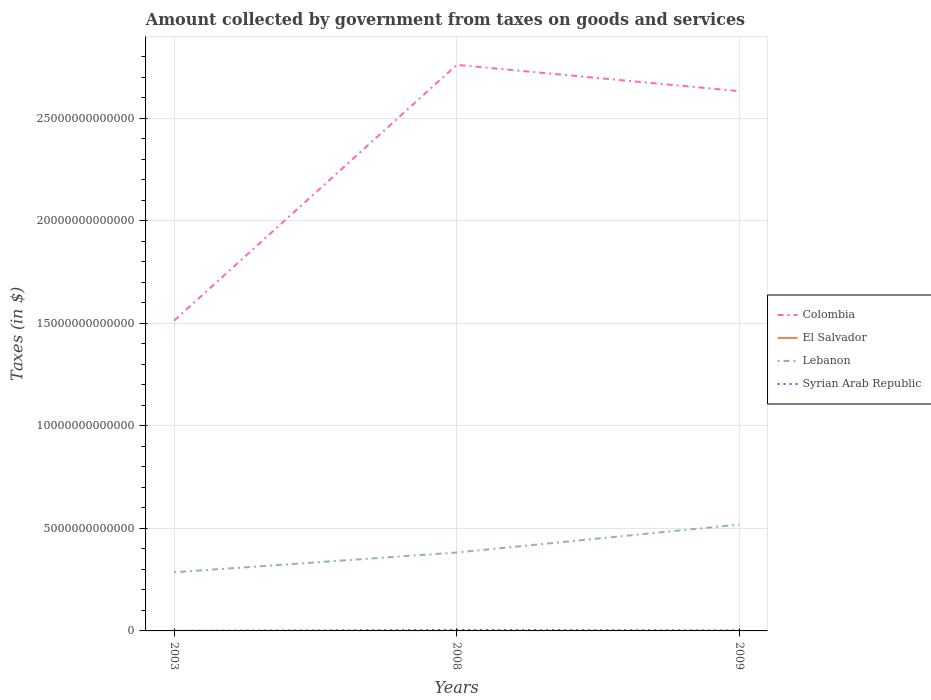Across all years, what is the maximum amount collected by government from taxes on goods and services in Syrian Arab Republic?
Offer a terse response. 3.82e+09. What is the total amount collected by government from taxes on goods and services in Lebanon in the graph?
Ensure brevity in your answer.  -9.64e+11. What is the difference between the highest and the second highest amount collected by government from taxes on goods and services in El Salvador?
Provide a short and direct response. 8.16e+08. Is the amount collected by government from taxes on goods and services in Syrian Arab Republic strictly greater than the amount collected by government from taxes on goods and services in El Salvador over the years?
Provide a short and direct response. No. What is the difference between two consecutive major ticks on the Y-axis?
Provide a succinct answer. 5.00e+12. Are the values on the major ticks of Y-axis written in scientific E-notation?
Your response must be concise. No. Does the graph contain grids?
Your answer should be very brief. Yes. How many legend labels are there?
Make the answer very short. 4. What is the title of the graph?
Your answer should be compact. Amount collected by government from taxes on goods and services. What is the label or title of the X-axis?
Make the answer very short. Years. What is the label or title of the Y-axis?
Keep it short and to the point. Taxes (in $). What is the Taxes (in $) of Colombia in 2003?
Give a very brief answer. 1.51e+13. What is the Taxes (in $) of El Salvador in 2003?
Ensure brevity in your answer.  9.86e+08. What is the Taxes (in $) of Lebanon in 2003?
Provide a short and direct response. 2.86e+12. What is the Taxes (in $) of Syrian Arab Republic in 2003?
Your answer should be compact. 3.82e+09. What is the Taxes (in $) in Colombia in 2008?
Ensure brevity in your answer.  2.76e+13. What is the Taxes (in $) in El Salvador in 2008?
Offer a terse response. 1.80e+09. What is the Taxes (in $) in Lebanon in 2008?
Offer a very short reply. 3.82e+12. What is the Taxes (in $) in Syrian Arab Republic in 2008?
Provide a succinct answer. 5.14e+1. What is the Taxes (in $) of Colombia in 2009?
Keep it short and to the point. 2.63e+13. What is the Taxes (in $) of El Salvador in 2009?
Offer a very short reply. 1.44e+09. What is the Taxes (in $) of Lebanon in 2009?
Offer a terse response. 5.18e+12. What is the Taxes (in $) of Syrian Arab Republic in 2009?
Ensure brevity in your answer.  2.60e+1. Across all years, what is the maximum Taxes (in $) of Colombia?
Your answer should be very brief. 2.76e+13. Across all years, what is the maximum Taxes (in $) in El Salvador?
Offer a very short reply. 1.80e+09. Across all years, what is the maximum Taxes (in $) in Lebanon?
Provide a succinct answer. 5.18e+12. Across all years, what is the maximum Taxes (in $) in Syrian Arab Republic?
Your answer should be very brief. 5.14e+1. Across all years, what is the minimum Taxes (in $) in Colombia?
Offer a terse response. 1.51e+13. Across all years, what is the minimum Taxes (in $) of El Salvador?
Provide a succinct answer. 9.86e+08. Across all years, what is the minimum Taxes (in $) in Lebanon?
Keep it short and to the point. 2.86e+12. Across all years, what is the minimum Taxes (in $) in Syrian Arab Republic?
Ensure brevity in your answer.  3.82e+09. What is the total Taxes (in $) of Colombia in the graph?
Keep it short and to the point. 6.90e+13. What is the total Taxes (in $) in El Salvador in the graph?
Your response must be concise. 4.23e+09. What is the total Taxes (in $) of Lebanon in the graph?
Give a very brief answer. 1.19e+13. What is the total Taxes (in $) in Syrian Arab Republic in the graph?
Make the answer very short. 8.12e+1. What is the difference between the Taxes (in $) of Colombia in 2003 and that in 2008?
Ensure brevity in your answer.  -1.25e+13. What is the difference between the Taxes (in $) in El Salvador in 2003 and that in 2008?
Offer a terse response. -8.16e+08. What is the difference between the Taxes (in $) of Lebanon in 2003 and that in 2008?
Your answer should be compact. -9.64e+11. What is the difference between the Taxes (in $) of Syrian Arab Republic in 2003 and that in 2008?
Offer a very short reply. -4.76e+1. What is the difference between the Taxes (in $) of Colombia in 2003 and that in 2009?
Your answer should be compact. -1.12e+13. What is the difference between the Taxes (in $) of El Salvador in 2003 and that in 2009?
Your response must be concise. -4.54e+08. What is the difference between the Taxes (in $) in Lebanon in 2003 and that in 2009?
Offer a very short reply. -2.33e+12. What is the difference between the Taxes (in $) in Syrian Arab Republic in 2003 and that in 2009?
Provide a short and direct response. -2.21e+1. What is the difference between the Taxes (in $) in Colombia in 2008 and that in 2009?
Provide a short and direct response. 1.28e+12. What is the difference between the Taxes (in $) of El Salvador in 2008 and that in 2009?
Provide a short and direct response. 3.62e+08. What is the difference between the Taxes (in $) in Lebanon in 2008 and that in 2009?
Your response must be concise. -1.36e+12. What is the difference between the Taxes (in $) in Syrian Arab Republic in 2008 and that in 2009?
Offer a very short reply. 2.54e+1. What is the difference between the Taxes (in $) of Colombia in 2003 and the Taxes (in $) of El Salvador in 2008?
Your answer should be very brief. 1.51e+13. What is the difference between the Taxes (in $) in Colombia in 2003 and the Taxes (in $) in Lebanon in 2008?
Your answer should be very brief. 1.13e+13. What is the difference between the Taxes (in $) in Colombia in 2003 and the Taxes (in $) in Syrian Arab Republic in 2008?
Offer a very short reply. 1.51e+13. What is the difference between the Taxes (in $) of El Salvador in 2003 and the Taxes (in $) of Lebanon in 2008?
Offer a terse response. -3.82e+12. What is the difference between the Taxes (in $) of El Salvador in 2003 and the Taxes (in $) of Syrian Arab Republic in 2008?
Give a very brief answer. -5.04e+1. What is the difference between the Taxes (in $) in Lebanon in 2003 and the Taxes (in $) in Syrian Arab Republic in 2008?
Provide a succinct answer. 2.81e+12. What is the difference between the Taxes (in $) in Colombia in 2003 and the Taxes (in $) in El Salvador in 2009?
Offer a very short reply. 1.51e+13. What is the difference between the Taxes (in $) in Colombia in 2003 and the Taxes (in $) in Lebanon in 2009?
Your answer should be very brief. 9.94e+12. What is the difference between the Taxes (in $) in Colombia in 2003 and the Taxes (in $) in Syrian Arab Republic in 2009?
Provide a succinct answer. 1.51e+13. What is the difference between the Taxes (in $) in El Salvador in 2003 and the Taxes (in $) in Lebanon in 2009?
Your answer should be very brief. -5.18e+12. What is the difference between the Taxes (in $) in El Salvador in 2003 and the Taxes (in $) in Syrian Arab Republic in 2009?
Keep it short and to the point. -2.50e+1. What is the difference between the Taxes (in $) in Lebanon in 2003 and the Taxes (in $) in Syrian Arab Republic in 2009?
Your answer should be very brief. 2.83e+12. What is the difference between the Taxes (in $) in Colombia in 2008 and the Taxes (in $) in El Salvador in 2009?
Provide a short and direct response. 2.76e+13. What is the difference between the Taxes (in $) of Colombia in 2008 and the Taxes (in $) of Lebanon in 2009?
Provide a short and direct response. 2.24e+13. What is the difference between the Taxes (in $) in Colombia in 2008 and the Taxes (in $) in Syrian Arab Republic in 2009?
Provide a succinct answer. 2.76e+13. What is the difference between the Taxes (in $) in El Salvador in 2008 and the Taxes (in $) in Lebanon in 2009?
Make the answer very short. -5.18e+12. What is the difference between the Taxes (in $) in El Salvador in 2008 and the Taxes (in $) in Syrian Arab Republic in 2009?
Your response must be concise. -2.42e+1. What is the difference between the Taxes (in $) of Lebanon in 2008 and the Taxes (in $) of Syrian Arab Republic in 2009?
Provide a succinct answer. 3.80e+12. What is the average Taxes (in $) in Colombia per year?
Your answer should be compact. 2.30e+13. What is the average Taxes (in $) of El Salvador per year?
Offer a terse response. 1.41e+09. What is the average Taxes (in $) in Lebanon per year?
Keep it short and to the point. 3.95e+12. What is the average Taxes (in $) of Syrian Arab Republic per year?
Your answer should be compact. 2.71e+1. In the year 2003, what is the difference between the Taxes (in $) of Colombia and Taxes (in $) of El Salvador?
Give a very brief answer. 1.51e+13. In the year 2003, what is the difference between the Taxes (in $) of Colombia and Taxes (in $) of Lebanon?
Make the answer very short. 1.23e+13. In the year 2003, what is the difference between the Taxes (in $) in Colombia and Taxes (in $) in Syrian Arab Republic?
Give a very brief answer. 1.51e+13. In the year 2003, what is the difference between the Taxes (in $) in El Salvador and Taxes (in $) in Lebanon?
Provide a short and direct response. -2.86e+12. In the year 2003, what is the difference between the Taxes (in $) in El Salvador and Taxes (in $) in Syrian Arab Republic?
Your answer should be very brief. -2.84e+09. In the year 2003, what is the difference between the Taxes (in $) of Lebanon and Taxes (in $) of Syrian Arab Republic?
Offer a terse response. 2.85e+12. In the year 2008, what is the difference between the Taxes (in $) in Colombia and Taxes (in $) in El Salvador?
Offer a terse response. 2.76e+13. In the year 2008, what is the difference between the Taxes (in $) of Colombia and Taxes (in $) of Lebanon?
Make the answer very short. 2.38e+13. In the year 2008, what is the difference between the Taxes (in $) of Colombia and Taxes (in $) of Syrian Arab Republic?
Your response must be concise. 2.75e+13. In the year 2008, what is the difference between the Taxes (in $) of El Salvador and Taxes (in $) of Lebanon?
Offer a very short reply. -3.82e+12. In the year 2008, what is the difference between the Taxes (in $) in El Salvador and Taxes (in $) in Syrian Arab Republic?
Ensure brevity in your answer.  -4.96e+1. In the year 2008, what is the difference between the Taxes (in $) in Lebanon and Taxes (in $) in Syrian Arab Republic?
Provide a short and direct response. 3.77e+12. In the year 2009, what is the difference between the Taxes (in $) of Colombia and Taxes (in $) of El Salvador?
Provide a succinct answer. 2.63e+13. In the year 2009, what is the difference between the Taxes (in $) in Colombia and Taxes (in $) in Lebanon?
Provide a short and direct response. 2.11e+13. In the year 2009, what is the difference between the Taxes (in $) of Colombia and Taxes (in $) of Syrian Arab Republic?
Provide a short and direct response. 2.63e+13. In the year 2009, what is the difference between the Taxes (in $) of El Salvador and Taxes (in $) of Lebanon?
Make the answer very short. -5.18e+12. In the year 2009, what is the difference between the Taxes (in $) of El Salvador and Taxes (in $) of Syrian Arab Republic?
Give a very brief answer. -2.45e+1. In the year 2009, what is the difference between the Taxes (in $) of Lebanon and Taxes (in $) of Syrian Arab Republic?
Ensure brevity in your answer.  5.16e+12. What is the ratio of the Taxes (in $) of Colombia in 2003 to that in 2008?
Your answer should be compact. 0.55. What is the ratio of the Taxes (in $) in El Salvador in 2003 to that in 2008?
Your answer should be very brief. 0.55. What is the ratio of the Taxes (in $) of Lebanon in 2003 to that in 2008?
Offer a terse response. 0.75. What is the ratio of the Taxes (in $) of Syrian Arab Republic in 2003 to that in 2008?
Provide a succinct answer. 0.07. What is the ratio of the Taxes (in $) of Colombia in 2003 to that in 2009?
Your response must be concise. 0.57. What is the ratio of the Taxes (in $) of El Salvador in 2003 to that in 2009?
Your answer should be very brief. 0.68. What is the ratio of the Taxes (in $) in Lebanon in 2003 to that in 2009?
Your answer should be very brief. 0.55. What is the ratio of the Taxes (in $) of Syrian Arab Republic in 2003 to that in 2009?
Your response must be concise. 0.15. What is the ratio of the Taxes (in $) in Colombia in 2008 to that in 2009?
Your answer should be very brief. 1.05. What is the ratio of the Taxes (in $) in El Salvador in 2008 to that in 2009?
Keep it short and to the point. 1.25. What is the ratio of the Taxes (in $) of Lebanon in 2008 to that in 2009?
Your response must be concise. 0.74. What is the ratio of the Taxes (in $) in Syrian Arab Republic in 2008 to that in 2009?
Provide a short and direct response. 1.98. What is the difference between the highest and the second highest Taxes (in $) of Colombia?
Your answer should be very brief. 1.28e+12. What is the difference between the highest and the second highest Taxes (in $) of El Salvador?
Keep it short and to the point. 3.62e+08. What is the difference between the highest and the second highest Taxes (in $) in Lebanon?
Offer a terse response. 1.36e+12. What is the difference between the highest and the second highest Taxes (in $) in Syrian Arab Republic?
Keep it short and to the point. 2.54e+1. What is the difference between the highest and the lowest Taxes (in $) in Colombia?
Make the answer very short. 1.25e+13. What is the difference between the highest and the lowest Taxes (in $) of El Salvador?
Your answer should be very brief. 8.16e+08. What is the difference between the highest and the lowest Taxes (in $) in Lebanon?
Your response must be concise. 2.33e+12. What is the difference between the highest and the lowest Taxes (in $) in Syrian Arab Republic?
Your answer should be very brief. 4.76e+1. 